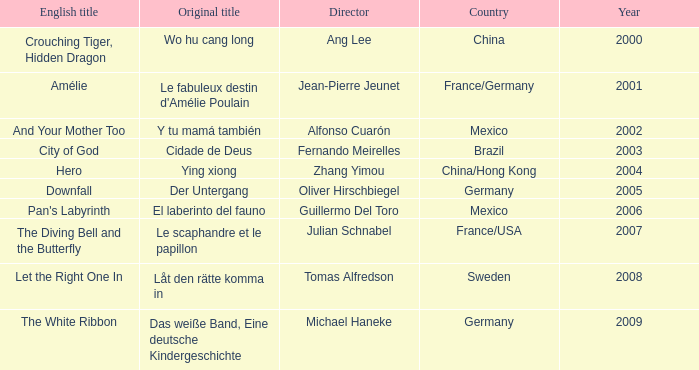Name the title of jean-pierre jeunet Amélie. 